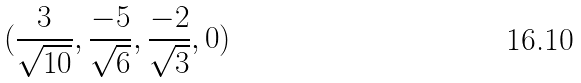<formula> <loc_0><loc_0><loc_500><loc_500>( \frac { 3 } { \sqrt { 1 0 } } , \frac { - 5 } { \sqrt { 6 } } , \frac { - 2 } { \sqrt { 3 } } , 0 )</formula> 